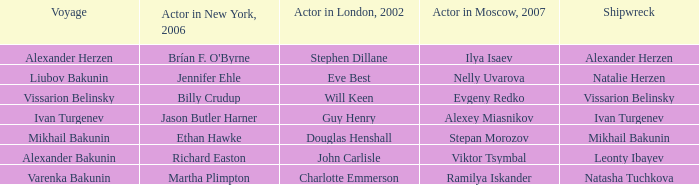Who was the actor in Moscow who did the part done by John Carlisle in London in 2002? Viktor Tsymbal. 